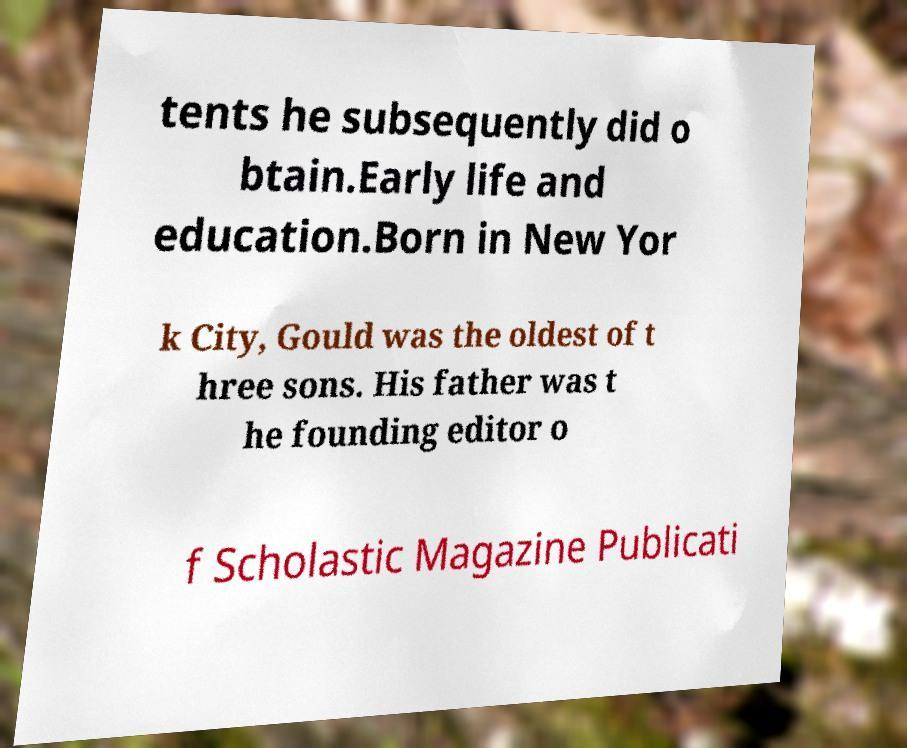Could you extract and type out the text from this image? tents he subsequently did o btain.Early life and education.Born in New Yor k City, Gould was the oldest of t hree sons. His father was t he founding editor o f Scholastic Magazine Publicati 